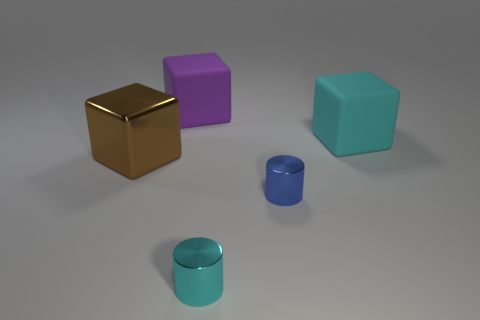Can you tell me the colors of the objects from left to right? From left to right, the objects are gold, purple, cyan, and blue. Each object has a glossy finish, reflecting the environment's light. 